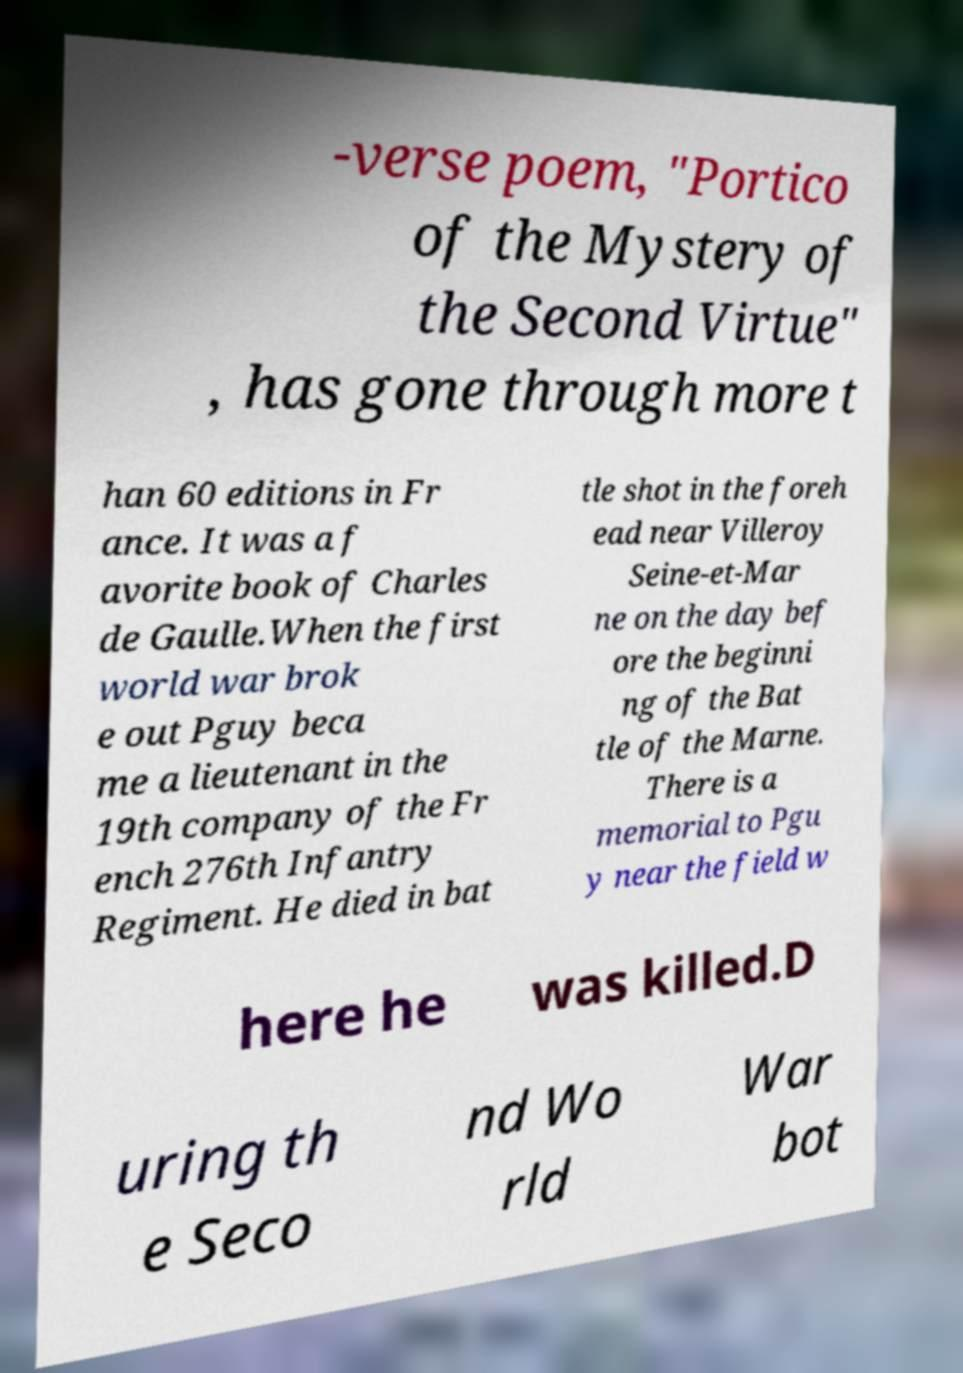Please read and relay the text visible in this image. What does it say? -verse poem, "Portico of the Mystery of the Second Virtue" , has gone through more t han 60 editions in Fr ance. It was a f avorite book of Charles de Gaulle.When the first world war brok e out Pguy beca me a lieutenant in the 19th company of the Fr ench 276th Infantry Regiment. He died in bat tle shot in the foreh ead near Villeroy Seine-et-Mar ne on the day bef ore the beginni ng of the Bat tle of the Marne. There is a memorial to Pgu y near the field w here he was killed.D uring th e Seco nd Wo rld War bot 